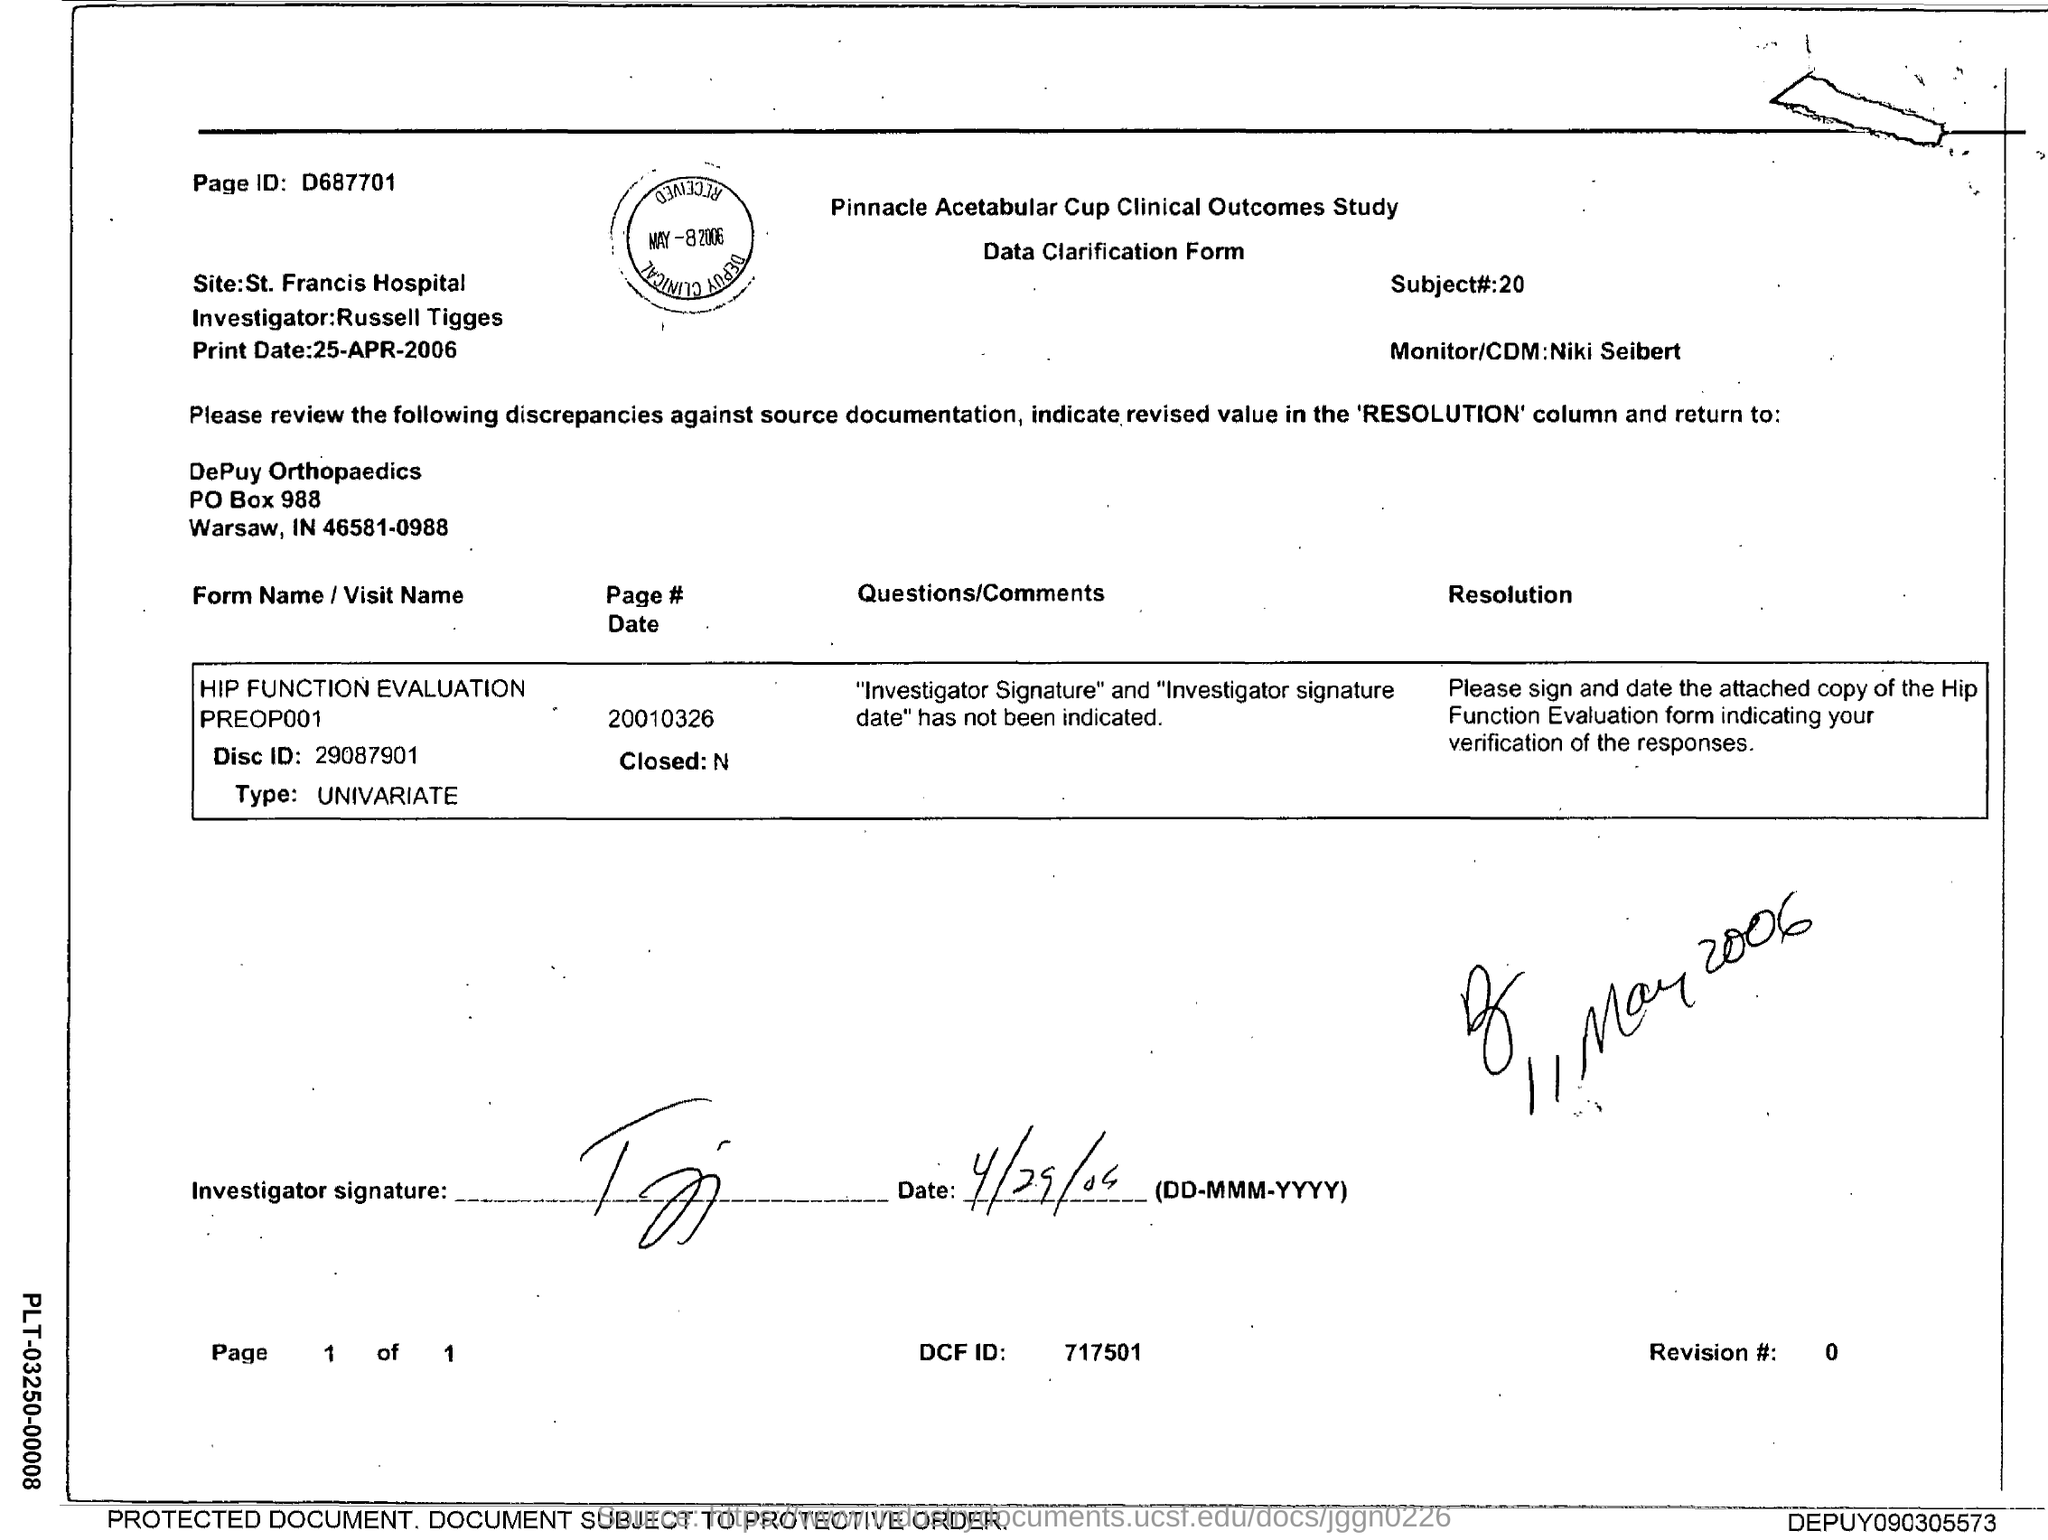Highlight a few significant elements in this photo. This document contains a page ID of D687701. 